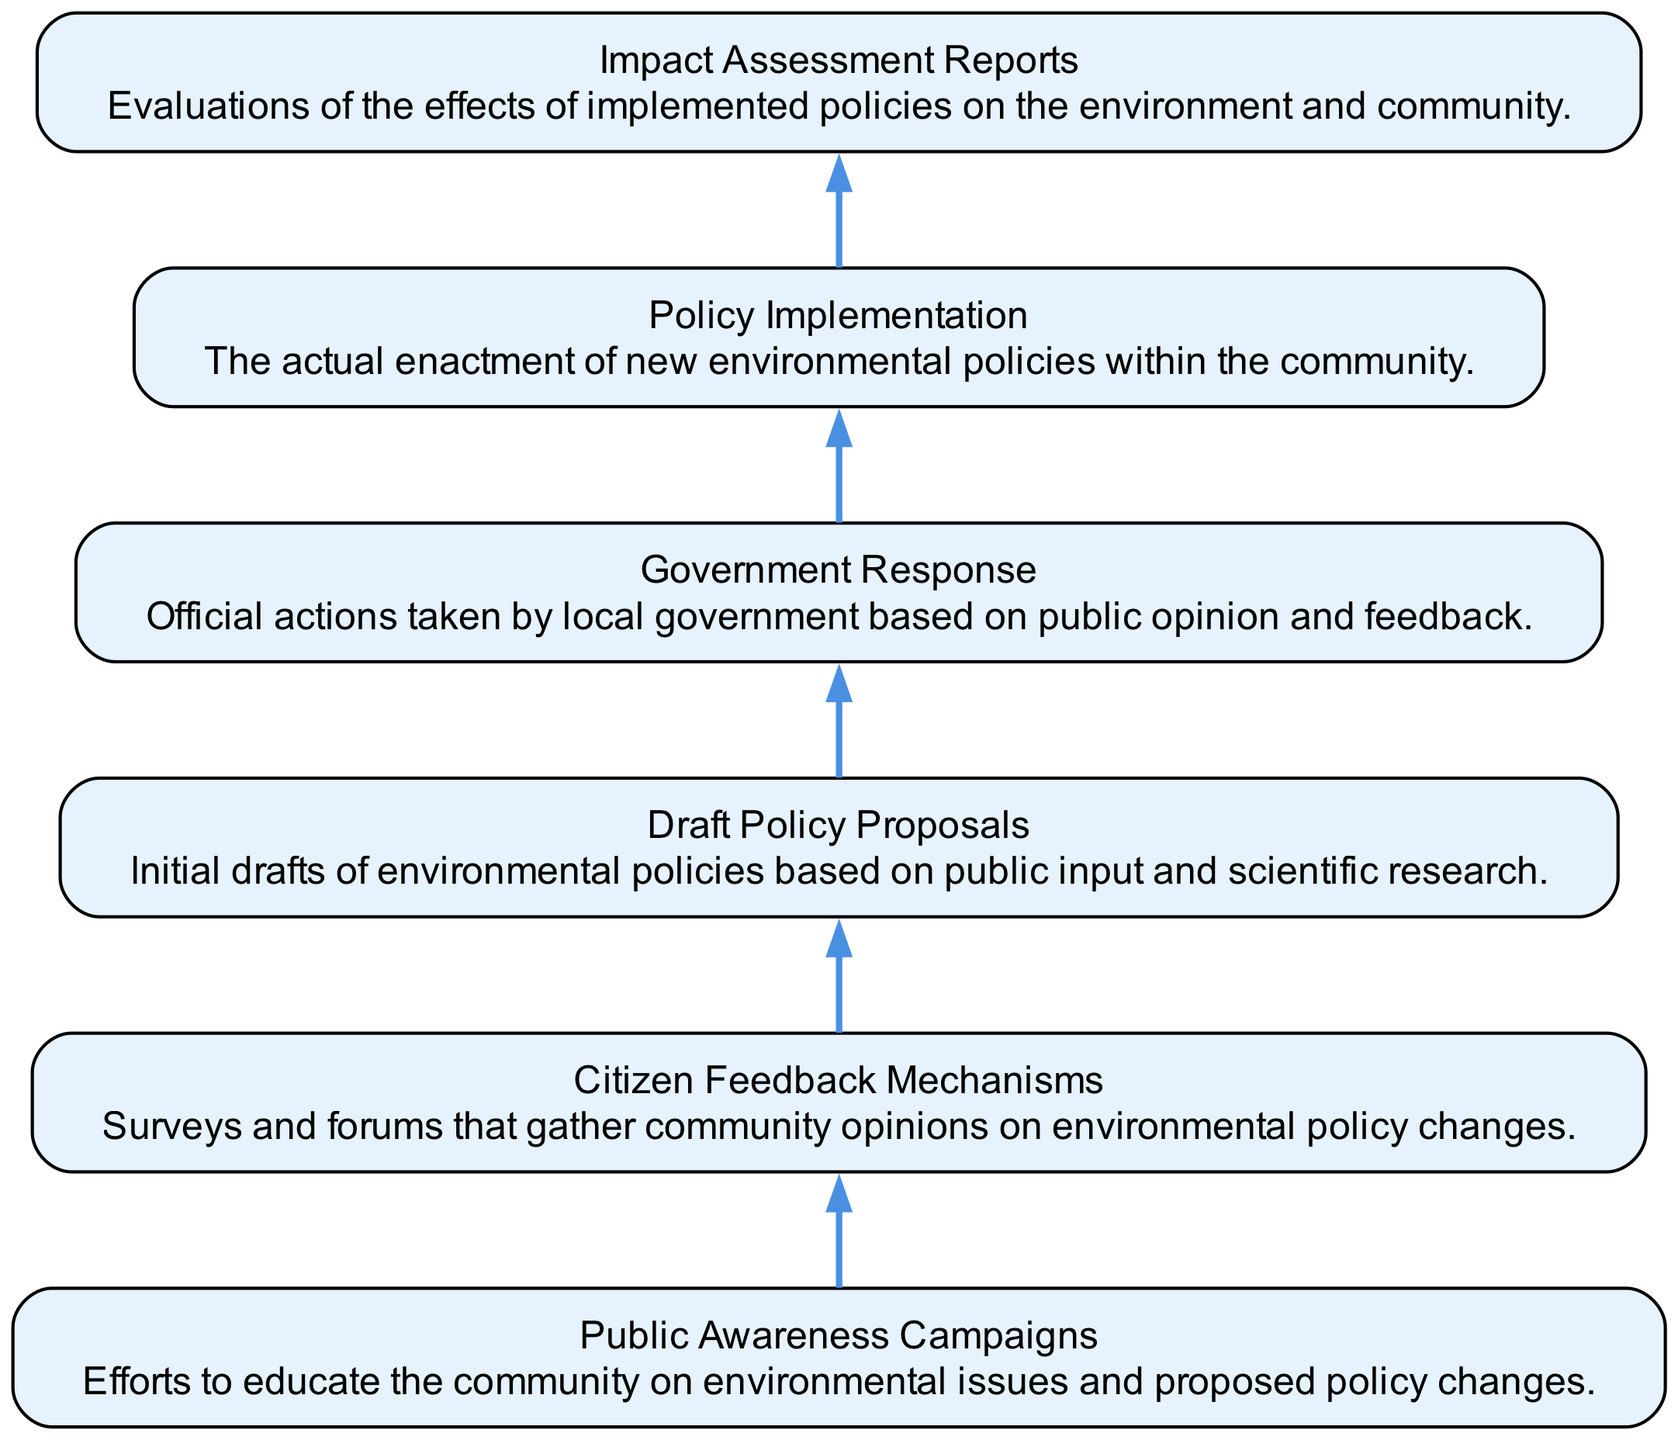What is the first node in the flow chart? The first node in the flow chart is labeled "Public Awareness Campaigns." It is the starting point of the flow, and no other nodes precede it.
Answer: Public Awareness Campaigns How many nodes are present in the diagram? The diagram has a total of six nodes. Each node represents a step in the process from public awareness to impact assessment.
Answer: Six What action follows "Citizen Feedback Mechanisms"? The action that follows "Citizen Feedback Mechanisms" is "Draft Policy Proposals". This is indicated by the directed edge leading from the citizen feedback node to the policy proposals node.
Answer: Draft Policy Proposals What is the last step in the flow chart? The last step in the flow chart is "Impact Assessment Reports." This is the end point for the flow of actions described in the diagram.
Answer: Impact Assessment Reports Which node directly precedes "Policy Implementation"? The node that directly precedes "Policy Implementation" is "Government Response." This can be seen from the flow direction indicated between these two nodes.
Answer: Government Response Explain the relationship between "Public Awareness Campaigns" and "Citizen Feedback Mechanisms." "Public Awareness Campaigns" leads to "Citizen Feedback Mechanisms." This indicates that increased public awareness is intended to elicit feedback from citizens regarding environmental policies.
Answer: Public Awareness Campaigns leads to Citizen Feedback Mechanisms In the flow from "Citizen Feedback Mechanisms" to "Impact Assessment Reports," how many steps are there? There are four steps in the flow from "Citizen Feedback Mechanisms" to "Impact Assessment Reports." They are: Citizen Feedback Mechanisms → Draft Policy Proposals → Government Response → Policy Implementation → Impact Assessment Reports.
Answer: Four steps What does the "Government Response" node represent? The "Government Response" node represents official actions that are taken by local government based on the gathered public opinion and feedback. It signifies a crucial decision-making point in response to citizens' opinions.
Answer: Official actions based on public opinion How does "Policy Implementation" relate to "Impact Assessment Reports"? "Policy Implementation" directly leads to "Impact Assessment Reports," indicating that after policies are enacted, their impacts are evaluated in the following step. This establishes a cause-and-effect relationship between implementing policies and assessing their outcomes.
Answer: Policy Implementation leads to Impact Assessment Reports 